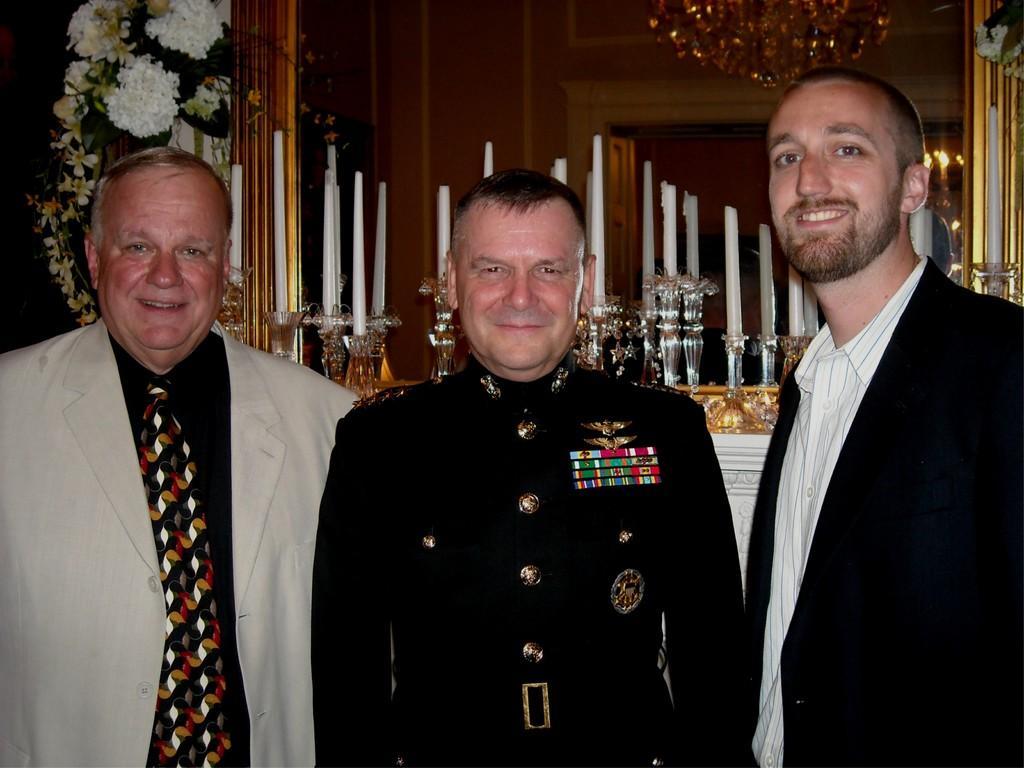Describe this image in one or two sentences. In this picture we can see there are three men standing. Behind the men there are flowers, mirror and candles with stands. On the mirror we can see the reflection of candle, lights, chandelier and a wall. 